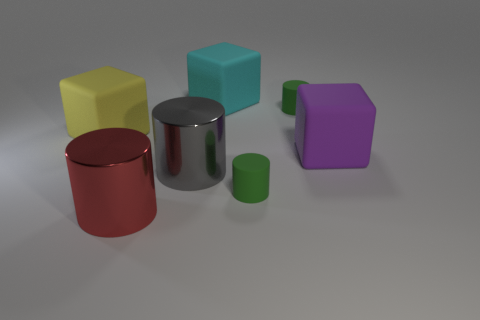What number of objects are either small gray rubber cubes or rubber cubes left of the cyan object?
Provide a succinct answer. 1. Are there more cyan things that are behind the big gray shiny cylinder than purple rubber objects that are behind the purple object?
Offer a terse response. Yes. What is the material of the big cube that is on the left side of the large cube that is behind the large block that is left of the cyan rubber thing?
Provide a short and direct response. Rubber. There is a cyan object that is the same material as the yellow cube; what shape is it?
Keep it short and to the point. Cube. There is a large red cylinder that is left of the large gray cylinder; is there a big yellow thing to the right of it?
Ensure brevity in your answer.  No. What size is the yellow matte block?
Provide a succinct answer. Large. What number of objects are either tiny purple rubber things or rubber cylinders?
Make the answer very short. 2. Is the block that is to the right of the cyan matte block made of the same material as the large gray cylinder that is in front of the big purple rubber cube?
Offer a terse response. No. There is another cylinder that is made of the same material as the big red cylinder; what is its color?
Your answer should be very brief. Gray. What number of yellow rubber things are the same size as the red cylinder?
Offer a very short reply. 1. 